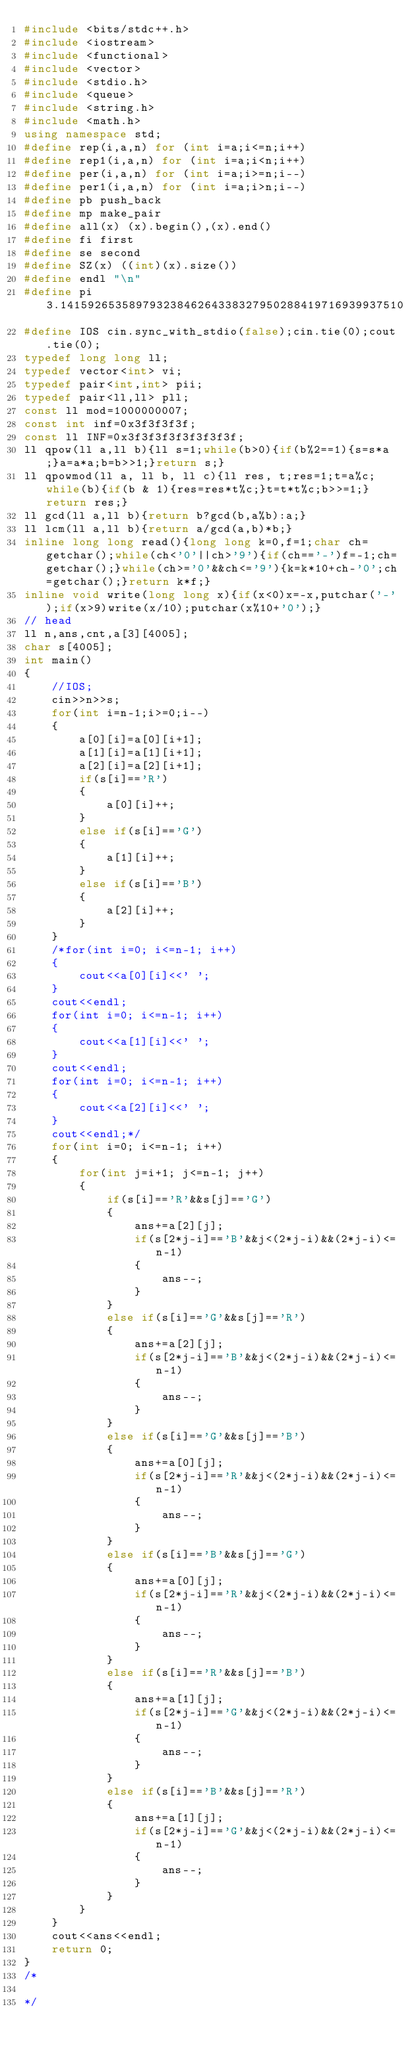Convert code to text. <code><loc_0><loc_0><loc_500><loc_500><_C++_>#include <bits/stdc++.h>
#include <iostream>
#include <functional>
#include <vector>
#include <stdio.h>
#include <queue>
#include <string.h>
#include <math.h>
using namespace std;
#define rep(i,a,n) for (int i=a;i<=n;i++)
#define rep1(i,a,n) for (int i=a;i<n;i++)
#define per(i,a,n) for (int i=a;i>=n;i--)
#define per1(i,a,n) for (int i=a;i>n;i--)
#define pb push_back
#define mp make_pair
#define all(x) (x).begin(),(x).end()
#define fi first
#define se second
#define SZ(x) ((int)(x).size())
#define endl "\n"
#define pi 3.14159265358979323846264338327950288419716939937510
#define IOS cin.sync_with_stdio(false);cin.tie(0);cout.tie(0);
typedef long long ll;
typedef vector<int> vi;
typedef pair<int,int> pii;
typedef pair<ll,ll> pll;
const ll mod=1000000007;
const int inf=0x3f3f3f3f;
const ll INF=0x3f3f3f3f3f3f3f3f;
ll qpow(ll a,ll b){ll s=1;while(b>0){if(b%2==1){s=s*a;}a=a*a;b=b>>1;}return s;}
ll qpowmod(ll a, ll b, ll c){ll res, t;res=1;t=a%c;while(b){if(b & 1){res=res*t%c;}t=t*t%c;b>>=1;}return res;}
ll gcd(ll a,ll b){return b?gcd(b,a%b):a;}
ll lcm(ll a,ll b){return a/gcd(a,b)*b;}
inline long long read(){long long k=0,f=1;char ch=getchar();while(ch<'0'||ch>'9'){if(ch=='-')f=-1;ch=getchar();}while(ch>='0'&&ch<='9'){k=k*10+ch-'0';ch=getchar();}return k*f;}
inline void write(long long x){if(x<0)x=-x,putchar('-');if(x>9)write(x/10);putchar(x%10+'0');}
// head
ll n,ans,cnt,a[3][4005];
char s[4005];
int main()
{
    //IOS;
    cin>>n>>s;
    for(int i=n-1;i>=0;i--)
    {
        a[0][i]=a[0][i+1];
        a[1][i]=a[1][i+1];
        a[2][i]=a[2][i+1];
        if(s[i]=='R')
        {
            a[0][i]++;
        }
        else if(s[i]=='G')
        {
            a[1][i]++;
        }
        else if(s[i]=='B')
        {
            a[2][i]++;
        }
    }
    /*for(int i=0; i<=n-1; i++)
    {
        cout<<a[0][i]<<' ';
    }
    cout<<endl;
    for(int i=0; i<=n-1; i++)
    {
        cout<<a[1][i]<<' ';
    }
    cout<<endl;
    for(int i=0; i<=n-1; i++)
    {
        cout<<a[2][i]<<' ';
    }
    cout<<endl;*/
    for(int i=0; i<=n-1; i++)
    {
        for(int j=i+1; j<=n-1; j++)
        {
            if(s[i]=='R'&&s[j]=='G')
            {
                ans+=a[2][j];
                if(s[2*j-i]=='B'&&j<(2*j-i)&&(2*j-i)<=n-1)
                {
                    ans--;
                }
            }
            else if(s[i]=='G'&&s[j]=='R')
            {
                ans+=a[2][j];
                if(s[2*j-i]=='B'&&j<(2*j-i)&&(2*j-i)<=n-1)
                {
                    ans--;
                }
            }
            else if(s[i]=='G'&&s[j]=='B')
            {
                ans+=a[0][j];
                if(s[2*j-i]=='R'&&j<(2*j-i)&&(2*j-i)<=n-1)
                {
                    ans--;
                }
            }
            else if(s[i]=='B'&&s[j]=='G')
            {
                ans+=a[0][j];
                if(s[2*j-i]=='R'&&j<(2*j-i)&&(2*j-i)<=n-1)
                {
                    ans--;
                }
            }
            else if(s[i]=='R'&&s[j]=='B')
            {
                ans+=a[1][j];
                if(s[2*j-i]=='G'&&j<(2*j-i)&&(2*j-i)<=n-1)
                {
                    ans--;
                }
            }
            else if(s[i]=='B'&&s[j]=='R')
            {
                ans+=a[1][j];
                if(s[2*j-i]=='G'&&j<(2*j-i)&&(2*j-i)<=n-1)
                {
                    ans--;
                }
            }
        }
    }
    cout<<ans<<endl;
    return 0;
}
/*

*/


</code> 